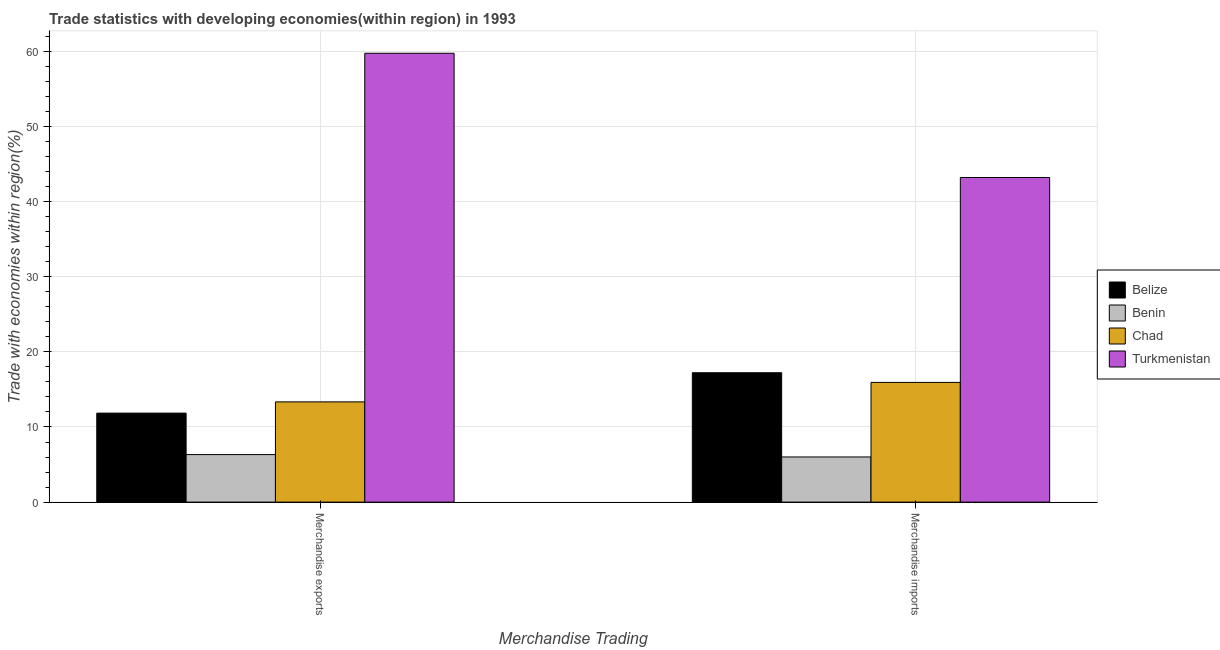How many different coloured bars are there?
Your answer should be very brief. 4. How many groups of bars are there?
Your answer should be compact. 2. Are the number of bars on each tick of the X-axis equal?
Your answer should be compact. Yes. What is the merchandise exports in Benin?
Offer a terse response. 6.33. Across all countries, what is the maximum merchandise exports?
Give a very brief answer. 59.73. Across all countries, what is the minimum merchandise imports?
Offer a terse response. 6.01. In which country was the merchandise exports maximum?
Give a very brief answer. Turkmenistan. In which country was the merchandise imports minimum?
Provide a succinct answer. Benin. What is the total merchandise imports in the graph?
Offer a terse response. 82.35. What is the difference between the merchandise exports in Chad and that in Benin?
Provide a short and direct response. 7.01. What is the difference between the merchandise imports in Benin and the merchandise exports in Belize?
Give a very brief answer. -5.83. What is the average merchandise imports per country?
Your response must be concise. 20.59. What is the difference between the merchandise exports and merchandise imports in Turkmenistan?
Ensure brevity in your answer.  16.53. In how many countries, is the merchandise imports greater than 22 %?
Your answer should be very brief. 1. What is the ratio of the merchandise imports in Chad to that in Belize?
Your response must be concise. 0.93. What does the 1st bar from the left in Merchandise imports represents?
Ensure brevity in your answer.  Belize. What does the 3rd bar from the right in Merchandise imports represents?
Ensure brevity in your answer.  Benin. How many countries are there in the graph?
Keep it short and to the point. 4. What is the difference between two consecutive major ticks on the Y-axis?
Keep it short and to the point. 10. Are the values on the major ticks of Y-axis written in scientific E-notation?
Your answer should be very brief. No. Does the graph contain any zero values?
Provide a short and direct response. No. Does the graph contain grids?
Provide a succinct answer. Yes. How many legend labels are there?
Provide a short and direct response. 4. What is the title of the graph?
Keep it short and to the point. Trade statistics with developing economies(within region) in 1993. What is the label or title of the X-axis?
Offer a very short reply. Merchandise Trading. What is the label or title of the Y-axis?
Offer a very short reply. Trade with economies within region(%). What is the Trade with economies within region(%) in Belize in Merchandise exports?
Keep it short and to the point. 11.84. What is the Trade with economies within region(%) in Benin in Merchandise exports?
Make the answer very short. 6.33. What is the Trade with economies within region(%) of Chad in Merchandise exports?
Provide a short and direct response. 13.34. What is the Trade with economies within region(%) in Turkmenistan in Merchandise exports?
Ensure brevity in your answer.  59.73. What is the Trade with economies within region(%) of Belize in Merchandise imports?
Keep it short and to the point. 17.22. What is the Trade with economies within region(%) in Benin in Merchandise imports?
Offer a terse response. 6.01. What is the Trade with economies within region(%) of Chad in Merchandise imports?
Offer a terse response. 15.93. What is the Trade with economies within region(%) of Turkmenistan in Merchandise imports?
Provide a short and direct response. 43.19. Across all Merchandise Trading, what is the maximum Trade with economies within region(%) in Belize?
Provide a short and direct response. 17.22. Across all Merchandise Trading, what is the maximum Trade with economies within region(%) in Benin?
Give a very brief answer. 6.33. Across all Merchandise Trading, what is the maximum Trade with economies within region(%) of Chad?
Ensure brevity in your answer.  15.93. Across all Merchandise Trading, what is the maximum Trade with economies within region(%) of Turkmenistan?
Give a very brief answer. 59.73. Across all Merchandise Trading, what is the minimum Trade with economies within region(%) of Belize?
Offer a very short reply. 11.84. Across all Merchandise Trading, what is the minimum Trade with economies within region(%) in Benin?
Offer a terse response. 6.01. Across all Merchandise Trading, what is the minimum Trade with economies within region(%) of Chad?
Offer a terse response. 13.34. Across all Merchandise Trading, what is the minimum Trade with economies within region(%) in Turkmenistan?
Make the answer very short. 43.19. What is the total Trade with economies within region(%) in Belize in the graph?
Your answer should be very brief. 29.06. What is the total Trade with economies within region(%) of Benin in the graph?
Make the answer very short. 12.33. What is the total Trade with economies within region(%) of Chad in the graph?
Offer a terse response. 29.27. What is the total Trade with economies within region(%) in Turkmenistan in the graph?
Keep it short and to the point. 102.92. What is the difference between the Trade with economies within region(%) in Belize in Merchandise exports and that in Merchandise imports?
Keep it short and to the point. -5.37. What is the difference between the Trade with economies within region(%) in Benin in Merchandise exports and that in Merchandise imports?
Provide a succinct answer. 0.32. What is the difference between the Trade with economies within region(%) in Chad in Merchandise exports and that in Merchandise imports?
Your answer should be compact. -2.59. What is the difference between the Trade with economies within region(%) in Turkmenistan in Merchandise exports and that in Merchandise imports?
Offer a very short reply. 16.53. What is the difference between the Trade with economies within region(%) of Belize in Merchandise exports and the Trade with economies within region(%) of Benin in Merchandise imports?
Give a very brief answer. 5.83. What is the difference between the Trade with economies within region(%) of Belize in Merchandise exports and the Trade with economies within region(%) of Chad in Merchandise imports?
Ensure brevity in your answer.  -4.09. What is the difference between the Trade with economies within region(%) of Belize in Merchandise exports and the Trade with economies within region(%) of Turkmenistan in Merchandise imports?
Your answer should be very brief. -31.35. What is the difference between the Trade with economies within region(%) in Benin in Merchandise exports and the Trade with economies within region(%) in Chad in Merchandise imports?
Provide a succinct answer. -9.61. What is the difference between the Trade with economies within region(%) in Benin in Merchandise exports and the Trade with economies within region(%) in Turkmenistan in Merchandise imports?
Your response must be concise. -36.87. What is the difference between the Trade with economies within region(%) in Chad in Merchandise exports and the Trade with economies within region(%) in Turkmenistan in Merchandise imports?
Make the answer very short. -29.86. What is the average Trade with economies within region(%) of Belize per Merchandise Trading?
Provide a short and direct response. 14.53. What is the average Trade with economies within region(%) of Benin per Merchandise Trading?
Keep it short and to the point. 6.17. What is the average Trade with economies within region(%) of Chad per Merchandise Trading?
Give a very brief answer. 14.64. What is the average Trade with economies within region(%) of Turkmenistan per Merchandise Trading?
Your answer should be compact. 51.46. What is the difference between the Trade with economies within region(%) in Belize and Trade with economies within region(%) in Benin in Merchandise exports?
Keep it short and to the point. 5.52. What is the difference between the Trade with economies within region(%) in Belize and Trade with economies within region(%) in Chad in Merchandise exports?
Your response must be concise. -1.49. What is the difference between the Trade with economies within region(%) in Belize and Trade with economies within region(%) in Turkmenistan in Merchandise exports?
Make the answer very short. -47.88. What is the difference between the Trade with economies within region(%) of Benin and Trade with economies within region(%) of Chad in Merchandise exports?
Give a very brief answer. -7.01. What is the difference between the Trade with economies within region(%) in Benin and Trade with economies within region(%) in Turkmenistan in Merchandise exports?
Your answer should be compact. -53.4. What is the difference between the Trade with economies within region(%) in Chad and Trade with economies within region(%) in Turkmenistan in Merchandise exports?
Your answer should be very brief. -46.39. What is the difference between the Trade with economies within region(%) in Belize and Trade with economies within region(%) in Benin in Merchandise imports?
Offer a terse response. 11.21. What is the difference between the Trade with economies within region(%) of Belize and Trade with economies within region(%) of Chad in Merchandise imports?
Your response must be concise. 1.29. What is the difference between the Trade with economies within region(%) in Belize and Trade with economies within region(%) in Turkmenistan in Merchandise imports?
Your response must be concise. -25.98. What is the difference between the Trade with economies within region(%) of Benin and Trade with economies within region(%) of Chad in Merchandise imports?
Your answer should be compact. -9.92. What is the difference between the Trade with economies within region(%) of Benin and Trade with economies within region(%) of Turkmenistan in Merchandise imports?
Provide a short and direct response. -37.18. What is the difference between the Trade with economies within region(%) in Chad and Trade with economies within region(%) in Turkmenistan in Merchandise imports?
Make the answer very short. -27.26. What is the ratio of the Trade with economies within region(%) in Belize in Merchandise exports to that in Merchandise imports?
Offer a terse response. 0.69. What is the ratio of the Trade with economies within region(%) in Benin in Merchandise exports to that in Merchandise imports?
Keep it short and to the point. 1.05. What is the ratio of the Trade with economies within region(%) in Chad in Merchandise exports to that in Merchandise imports?
Your answer should be compact. 0.84. What is the ratio of the Trade with economies within region(%) in Turkmenistan in Merchandise exports to that in Merchandise imports?
Keep it short and to the point. 1.38. What is the difference between the highest and the second highest Trade with economies within region(%) in Belize?
Provide a short and direct response. 5.37. What is the difference between the highest and the second highest Trade with economies within region(%) of Benin?
Provide a short and direct response. 0.32. What is the difference between the highest and the second highest Trade with economies within region(%) of Chad?
Ensure brevity in your answer.  2.59. What is the difference between the highest and the second highest Trade with economies within region(%) of Turkmenistan?
Your answer should be very brief. 16.53. What is the difference between the highest and the lowest Trade with economies within region(%) in Belize?
Provide a succinct answer. 5.37. What is the difference between the highest and the lowest Trade with economies within region(%) in Benin?
Offer a very short reply. 0.32. What is the difference between the highest and the lowest Trade with economies within region(%) in Chad?
Provide a succinct answer. 2.59. What is the difference between the highest and the lowest Trade with economies within region(%) of Turkmenistan?
Your response must be concise. 16.53. 